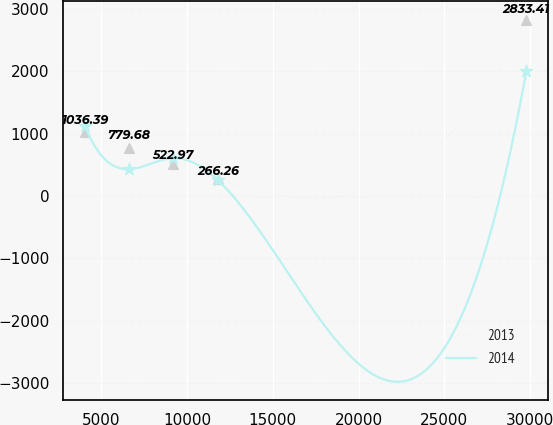<chart> <loc_0><loc_0><loc_500><loc_500><line_chart><ecel><fcel>2013<fcel>2014<nl><fcel>4032.95<fcel>1036.39<fcel>1131.83<nl><fcel>6607.27<fcel>779.68<fcel>432.39<nl><fcel>9181.59<fcel>522.97<fcel>607.4<nl><fcel>11813.1<fcel>266.26<fcel>252.84<nl><fcel>29776.2<fcel>2833.41<fcel>2002.93<nl></chart> 